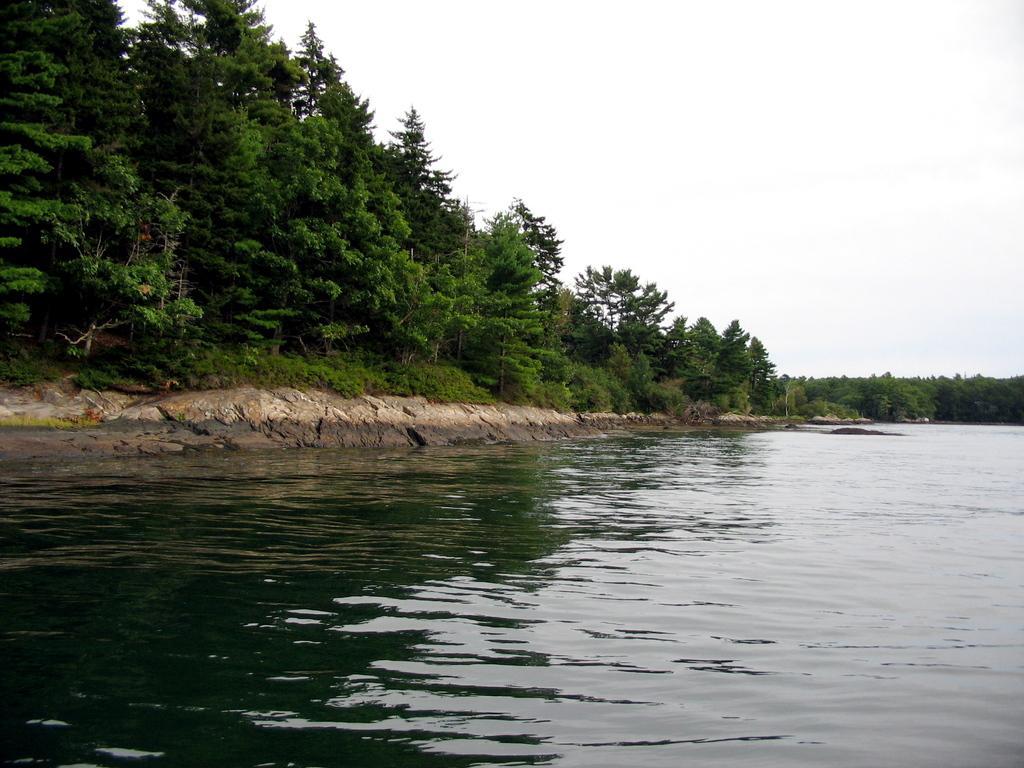Please provide a concise description of this image. In the foreground of the picture we can see a water body. On the left there are trees and plants. In the background towards right there are trees. At the top there is sky. 